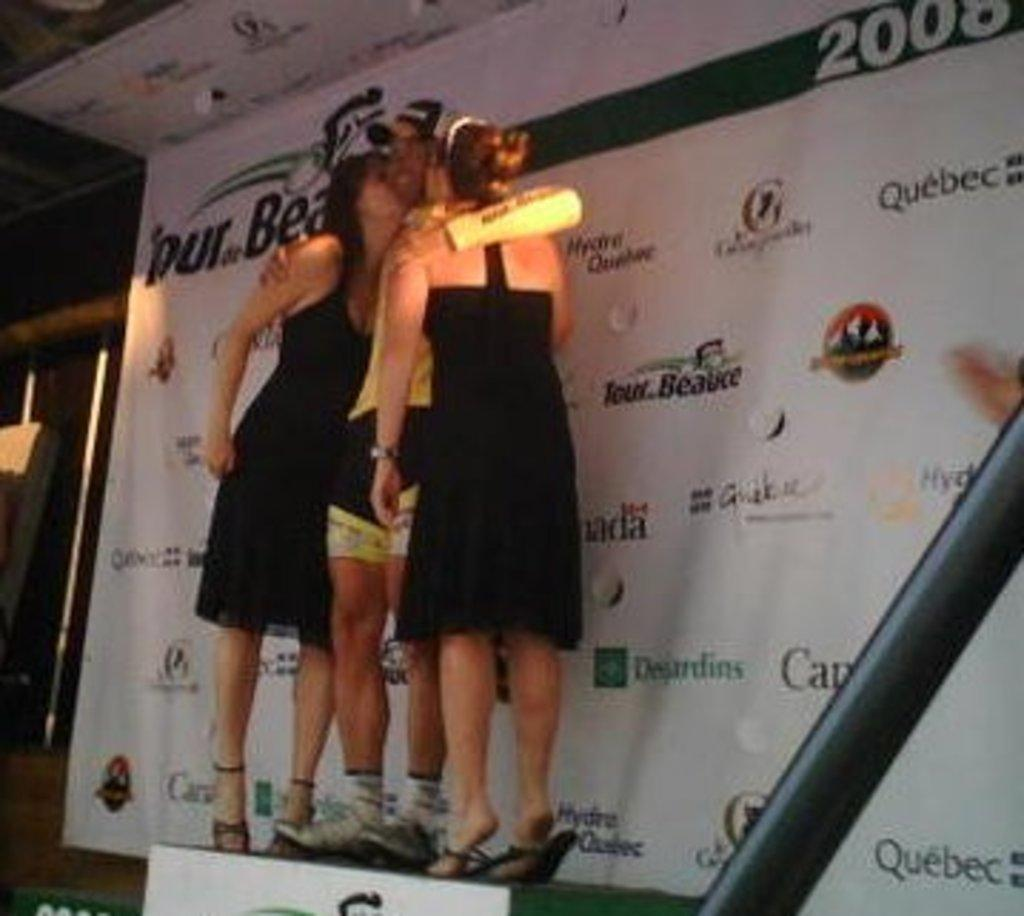How many people are in the image? There are two women and a man in the image. What are the people in the image doing? The two women are kissing the man in the middle. Where are the people standing in the image? The two women and the man are standing on a stand. What can be seen on the right side of the image? There is a hoarding on the right side of the image. How many dolls are sitting on the bag in the image? There are no dolls or bags present in the image. What type of flower is growing on the stand with the people? There is no flower visible in the image; it only features the two women, the man, and the hoarding. 